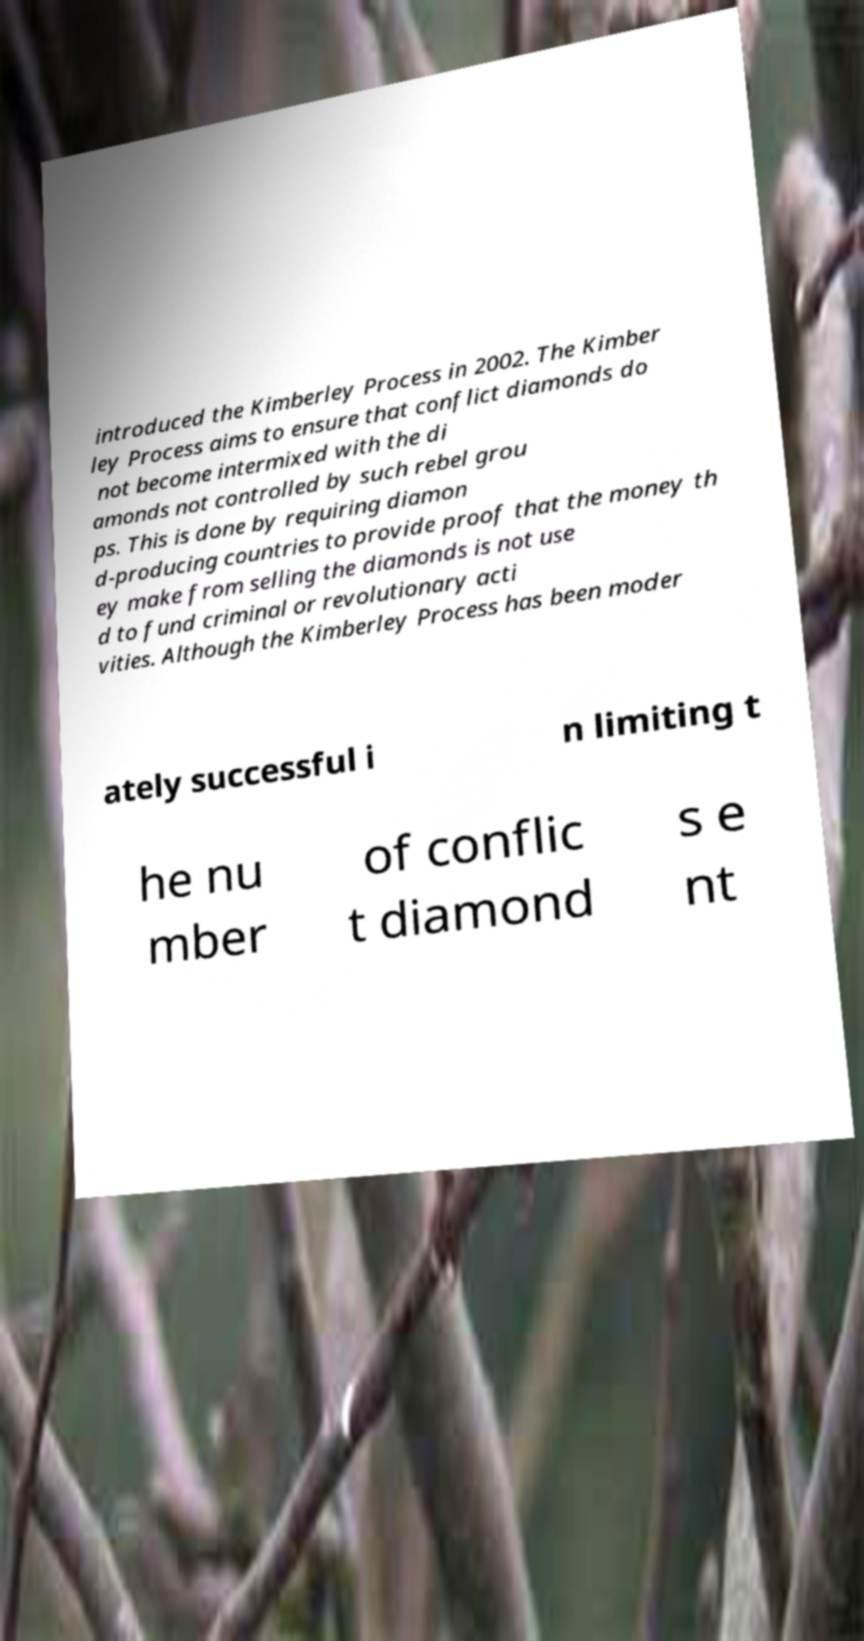Can you accurately transcribe the text from the provided image for me? introduced the Kimberley Process in 2002. The Kimber ley Process aims to ensure that conflict diamonds do not become intermixed with the di amonds not controlled by such rebel grou ps. This is done by requiring diamon d-producing countries to provide proof that the money th ey make from selling the diamonds is not use d to fund criminal or revolutionary acti vities. Although the Kimberley Process has been moder ately successful i n limiting t he nu mber of conflic t diamond s e nt 